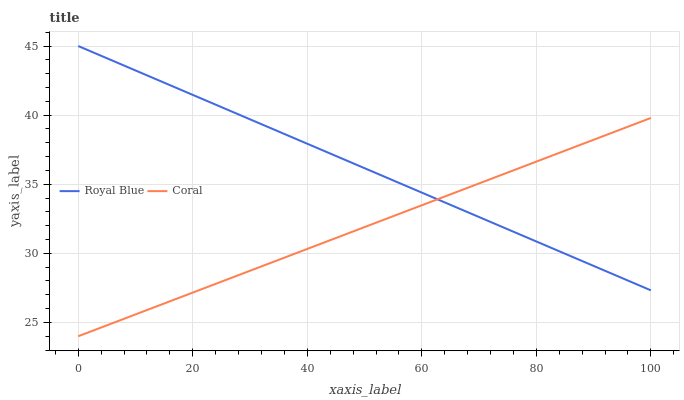Does Coral have the minimum area under the curve?
Answer yes or no. Yes. Does Royal Blue have the maximum area under the curve?
Answer yes or no. Yes. Does Coral have the maximum area under the curve?
Answer yes or no. No. Is Coral the smoothest?
Answer yes or no. Yes. Is Royal Blue the roughest?
Answer yes or no. Yes. Is Coral the roughest?
Answer yes or no. No. Does Royal Blue have the highest value?
Answer yes or no. Yes. Does Coral have the highest value?
Answer yes or no. No. Does Coral intersect Royal Blue?
Answer yes or no. Yes. Is Coral less than Royal Blue?
Answer yes or no. No. Is Coral greater than Royal Blue?
Answer yes or no. No. 